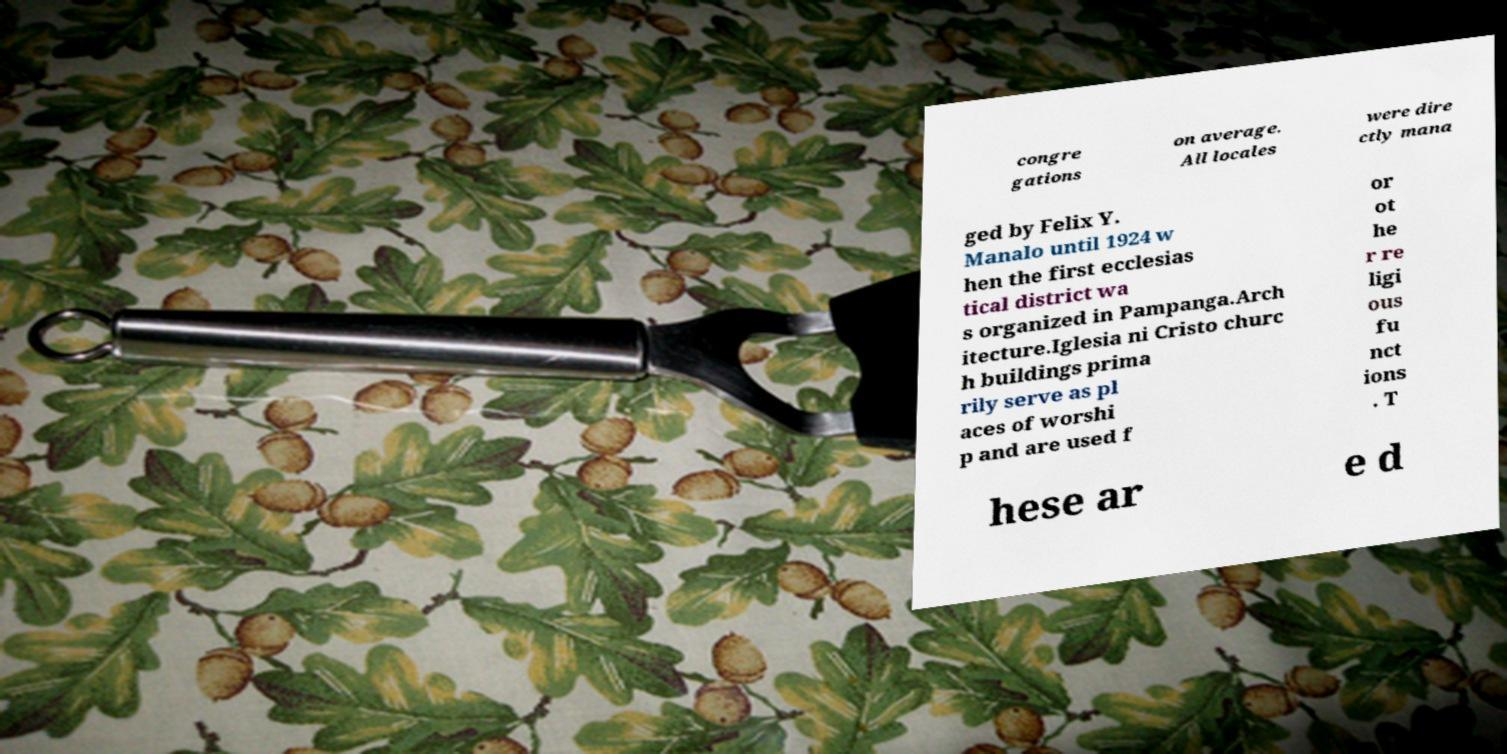Please identify and transcribe the text found in this image. congre gations on average. All locales were dire ctly mana ged by Felix Y. Manalo until 1924 w hen the first ecclesias tical district wa s organized in Pampanga.Arch itecture.Iglesia ni Cristo churc h buildings prima rily serve as pl aces of worshi p and are used f or ot he r re ligi ous fu nct ions . T hese ar e d 